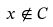<formula> <loc_0><loc_0><loc_500><loc_500>x \notin C</formula> 